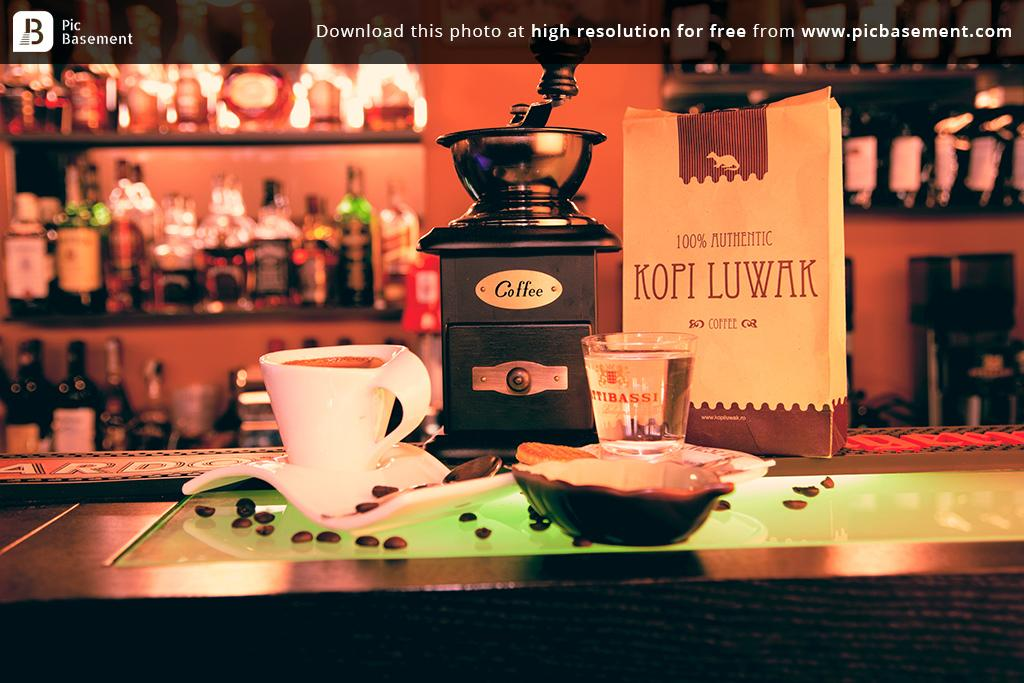<image>
Present a compact description of the photo's key features. an icon in the top left that says pic basement 